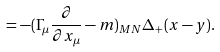<formula> <loc_0><loc_0><loc_500><loc_500>= - ( \Gamma _ { \mu } \frac { \partial } { \partial x _ { \mu } } - m ) _ { M N } \Delta _ { + } ( x - y ) .</formula> 